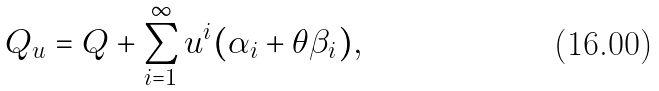<formula> <loc_0><loc_0><loc_500><loc_500>Q _ { u } = Q + \sum _ { i = 1 } ^ { \infty } u ^ { i } ( \alpha _ { i } + \theta \beta _ { i } ) ,</formula> 